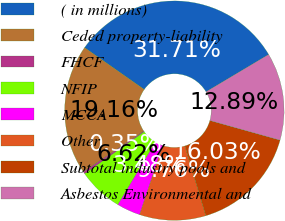<chart> <loc_0><loc_0><loc_500><loc_500><pie_chart><fcel>( in millions)<fcel>Ceded property-liability<fcel>FHCF<fcel>NFIP<fcel>MCCA<fcel>Other<fcel>Subtotal industry pools and<fcel>Asbestos Environmental and<nl><fcel>31.71%<fcel>19.16%<fcel>0.35%<fcel>6.62%<fcel>3.48%<fcel>9.76%<fcel>16.03%<fcel>12.89%<nl></chart> 